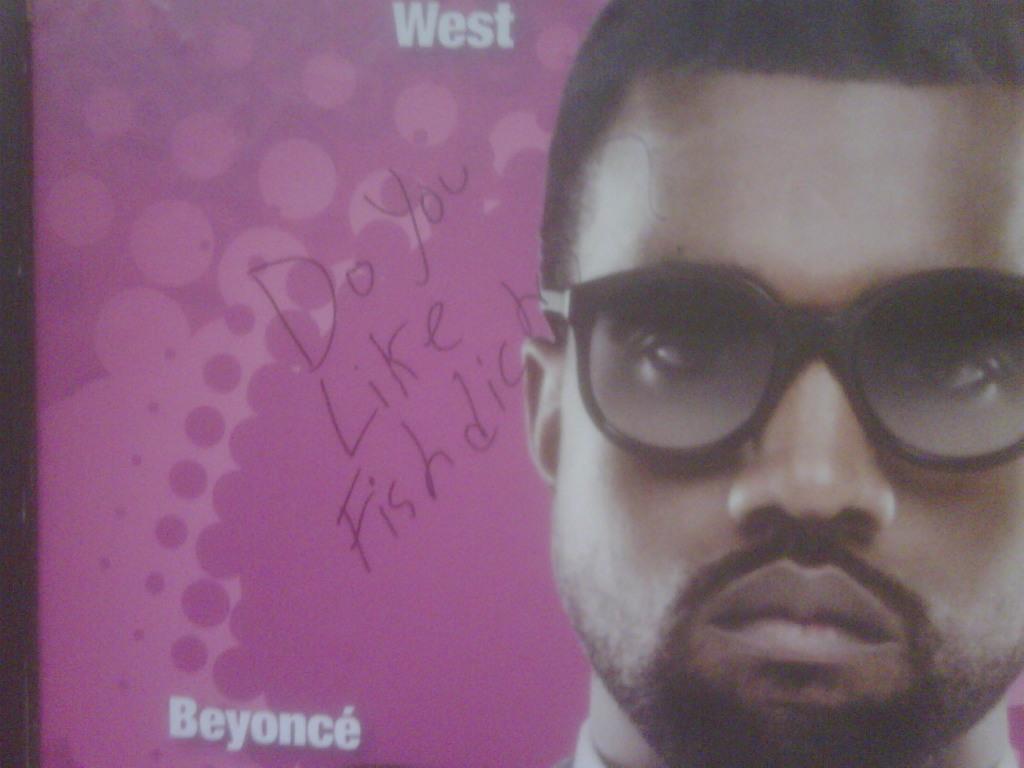Can you describe this image briefly? On the right side, there is a person wearing a spectacle. On the left side, there are white and other colored texts and designs on the poster. And the background is pink in color. 